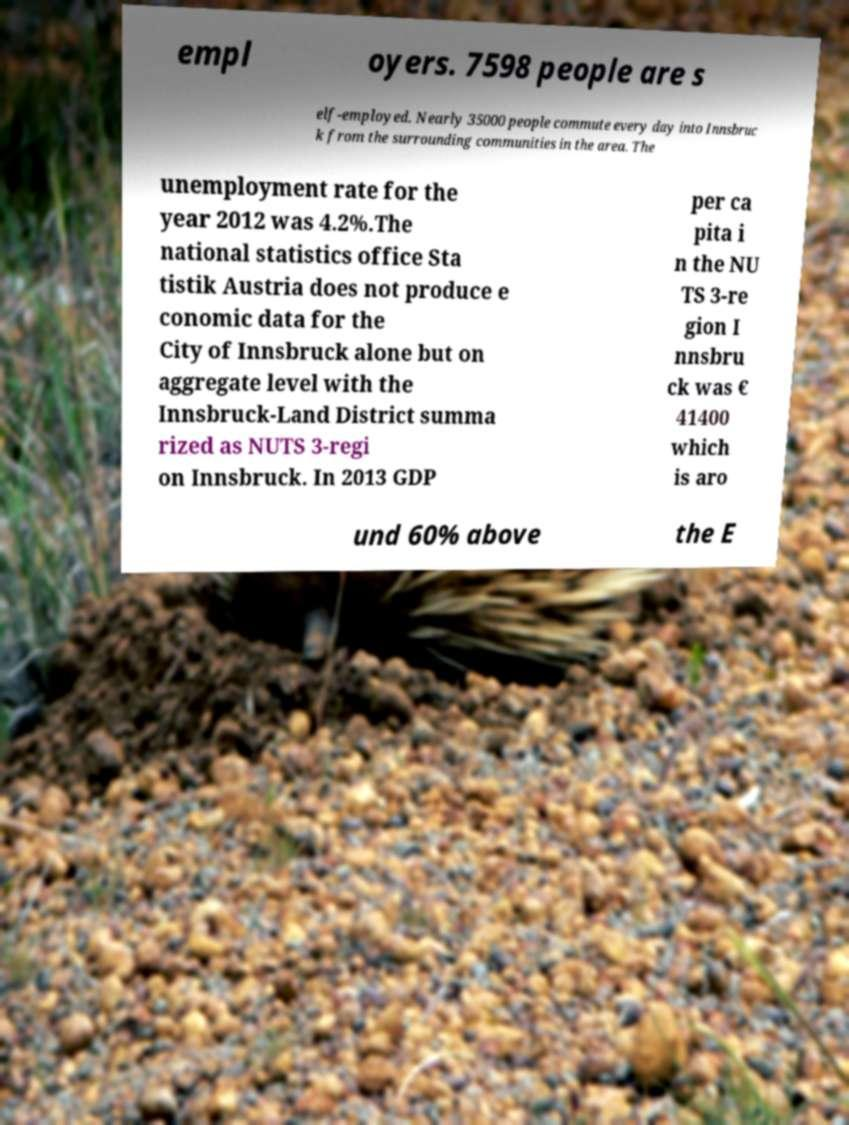Could you extract and type out the text from this image? empl oyers. 7598 people are s elf-employed. Nearly 35000 people commute every day into Innsbruc k from the surrounding communities in the area. The unemployment rate for the year 2012 was 4.2%.The national statistics office Sta tistik Austria does not produce e conomic data for the City of Innsbruck alone but on aggregate level with the Innsbruck-Land District summa rized as NUTS 3-regi on Innsbruck. In 2013 GDP per ca pita i n the NU TS 3-re gion I nnsbru ck was € 41400 which is aro und 60% above the E 